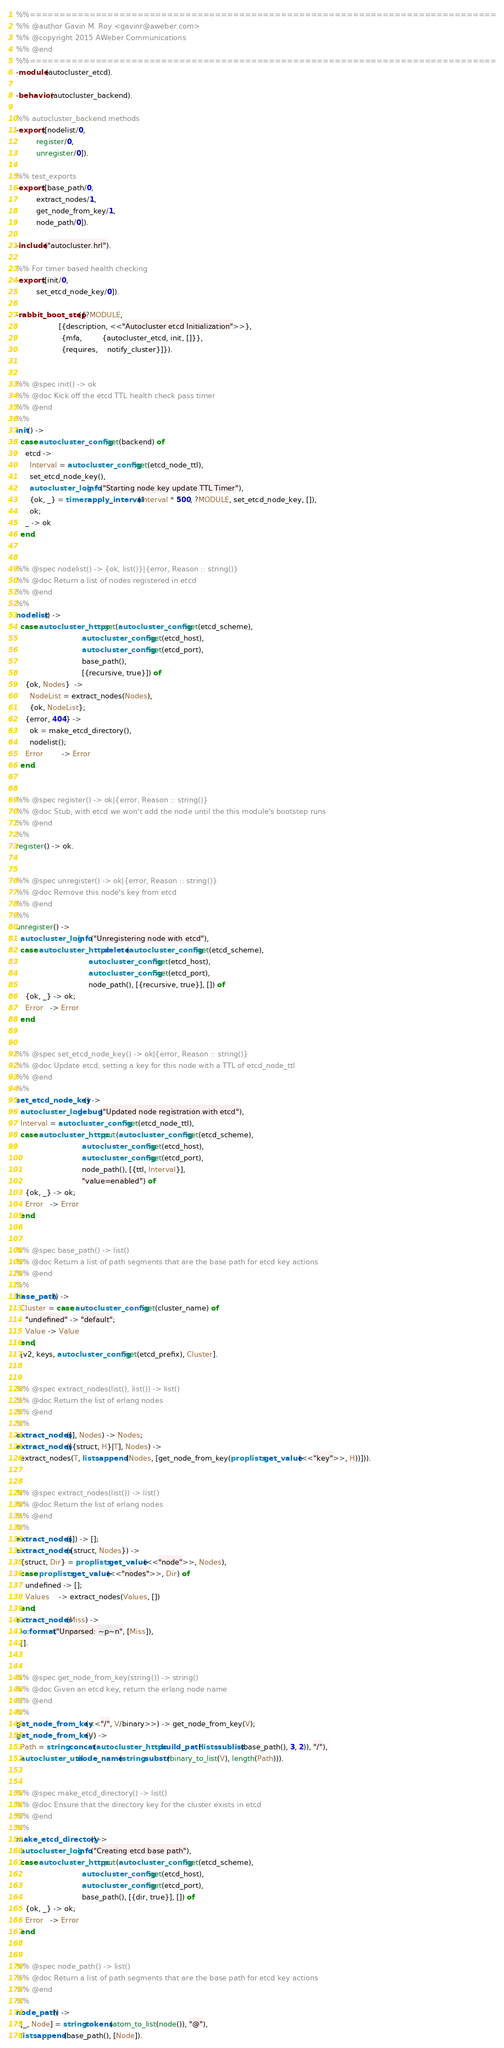<code> <loc_0><loc_0><loc_500><loc_500><_Erlang_>%%==============================================================================
%% @author Gavin M. Roy <gavinr@aweber.com>
%% @copyright 2015 AWeber Communications
%% @end
%%==============================================================================
-module(autocluster_etcd).

-behavior(autocluster_backend).

%% autocluster_backend methods
-export([nodelist/0,
         register/0,
         unregister/0]).

%% test_exports
-export([base_path/0,
         extract_nodes/1,
         get_node_from_key/1,
         node_path/0]).

-include("autocluster.hrl").

%% For timer based health checking
-export([init/0,
         set_etcd_node_key/0]).

-rabbit_boot_step({?MODULE,
                   [{description, <<"Autocluster etcd Initialization">>},
                    {mfa,         {autocluster_etcd, init, []}},
                    {requires,    notify_cluster}]}).


%% @spec init() -> ok
%% @doc Kick off the etcd TTL health check pass timer
%% @end
%%
init() ->
  case autocluster_config:get(backend) of
    etcd ->
      Interval = autocluster_config:get(etcd_node_ttl),
      set_etcd_node_key(),
      autocluster_log:info("Starting node key update TTL Timer"),
      {ok, _} = timer:apply_interval(Interval * 500, ?MODULE, set_etcd_node_key, []),
      ok;
    _ -> ok
  end.


%% @spec nodelist() -> {ok, list()}|{error, Reason :: string()}
%% @doc Return a list of nodes registered in etcd
%% @end
%%
nodelist() ->
  case autocluster_httpc:get(autocluster_config:get(etcd_scheme),
                             autocluster_config:get(etcd_host),
                             autocluster_config:get(etcd_port),
                             base_path(),
                             [{recursive, true}]) of
    {ok, Nodes}  ->
      NodeList = extract_nodes(Nodes),
      {ok, NodeList};
    {error, 404} ->
      ok = make_etcd_directory(),
      nodelist();
    Error        -> Error
  end.


%% @spec register() -> ok|{error, Reason :: string()}
%% @doc Stub, with etcd we won't add the node until the this module's bootstep runs
%% @end
%%
register() -> ok.


%% @spec unregister() -> ok|{error, Reason :: string()}
%% @doc Remove this node's key from etcd
%% @end
%%
unregister() ->
  autocluster_log:info("Unregistering node with etcd"),
  case autocluster_httpc:delete(autocluster_config:get(etcd_scheme),
                                autocluster_config:get(etcd_host),
                                autocluster_config:get(etcd_port),
                                node_path(), [{recursive, true}], []) of
    {ok, _} -> ok;
    Error   -> Error
  end.


%% @spec set_etcd_node_key() -> ok|{error, Reason :: string()}
%% @doc Update etcd, setting a key for this node with a TTL of etcd_node_ttl
%% @end
%%
set_etcd_node_key() ->
  autocluster_log:debug("Updated node registration with etcd"),
  Interval = autocluster_config:get(etcd_node_ttl),
  case autocluster_httpc:put(autocluster_config:get(etcd_scheme),
                             autocluster_config:get(etcd_host),
                             autocluster_config:get(etcd_port),
                             node_path(), [{ttl, Interval}],
                             "value=enabled") of
    {ok, _} -> ok;
    Error   -> Error
  end.


%% @spec base_path() -> list()
%% @doc Return a list of path segments that are the base path for etcd key actions
%% @end
%%
base_path() ->
  Cluster = case autocluster_config:get(cluster_name) of
    "undefined" -> "default";
    Value -> Value
  end,
  [v2, keys, autocluster_config:get(etcd_prefix), Cluster].


%% @spec extract_nodes(list(), list()) -> list()
%% @doc Return the list of erlang nodes
%% @end
%%
extract_nodes([], Nodes) -> Nodes;
extract_nodes([{struct, H}|T], Nodes) ->
  extract_nodes(T, lists:append(Nodes, [get_node_from_key(proplists:get_value(<<"key">>, H))])).


%% @spec extract_nodes(list()) -> list()
%% @doc Return the list of erlang nodes
%% @end
%%
extract_nodes([]) -> [];
extract_nodes({struct, Nodes}) ->
  {struct, Dir} = proplists:get_value(<<"node">>, Nodes),
  case proplists:get_value(<<"nodes">>, Dir) of
    undefined -> [];
    Values    -> extract_nodes(Values, [])
  end;
extract_nodes(Miss) ->
  io:format("Unparsed: ~p~n", [Miss]),
  [].


%% @spec get_node_from_key(string()) -> string()
%% @doc Given an etcd key, return the erlang node name
%% @end
%%
get_node_from_key(<<"/", V/binary>>) -> get_node_from_key(V);
get_node_from_key(V) ->
  Path = string:concat(autocluster_httpc:build_path(lists:sublist(base_path(), 3, 2)), "/"),
  autocluster_util:node_name(string:substr(binary_to_list(V), length(Path))).


%% @spec make_etcd_directory() -> list()
%% @doc Ensure that the directory key for the cluster exists in etcd
%% @end
%%
make_etcd_directory() ->
  autocluster_log:info("Creating etcd base path"),
  case autocluster_httpc:put(autocluster_config:get(etcd_scheme),
                             autocluster_config:get(etcd_host),
                             autocluster_config:get(etcd_port),
                             base_path(), [{dir, true}], []) of
    {ok, _} -> ok;
    Error   -> Error
  end.


%% @spec node_path() -> list()
%% @doc Return a list of path segments that are the base path for etcd key actions
%% @end
%%
node_path() ->
  [_, Node] = string:tokens(atom_to_list(node()), "@"),
  lists:append(base_path(), [Node]).
</code> 